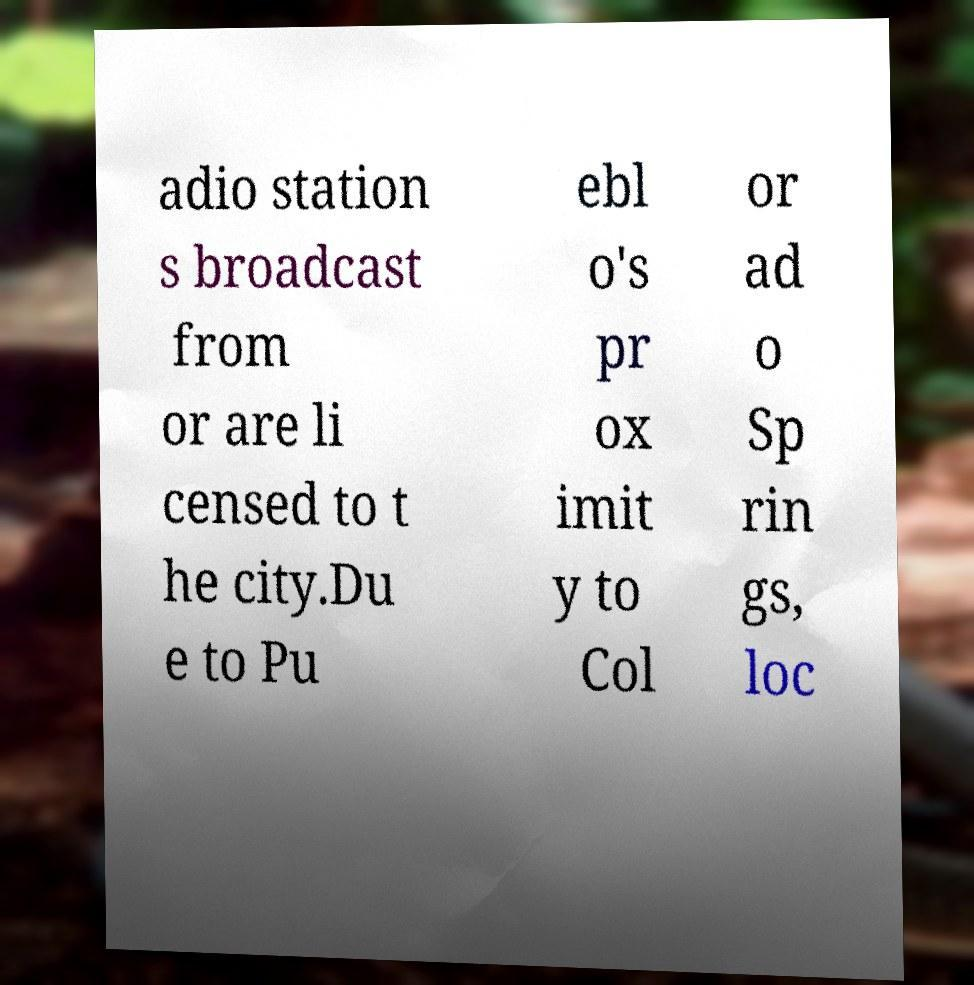Please read and relay the text visible in this image. What does it say? adio station s broadcast from or are li censed to t he city.Du e to Pu ebl o's pr ox imit y to Col or ad o Sp rin gs, loc 